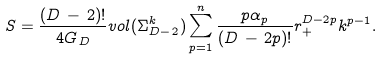<formula> <loc_0><loc_0><loc_500><loc_500>S = \frac { ( D \, - \, 2 ) ! } { 4 G _ { \, D } } v o l ( \Sigma _ { D - \, 2 } ^ { k } ) \sum _ { p = 1 } ^ { n } \frac { p \alpha _ { p } } { ( D \, - \, 2 p ) ! } r _ { + } ^ { D - 2 p } k ^ { p - 1 } .</formula> 